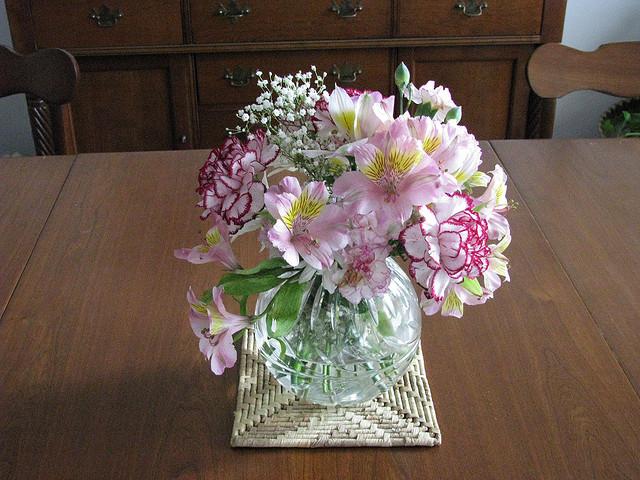How many chairs are in the image?
Quick response, please. 2. What is in the vase?
Keep it brief. Flowers. Are these faux flowers?
Write a very short answer. No. 